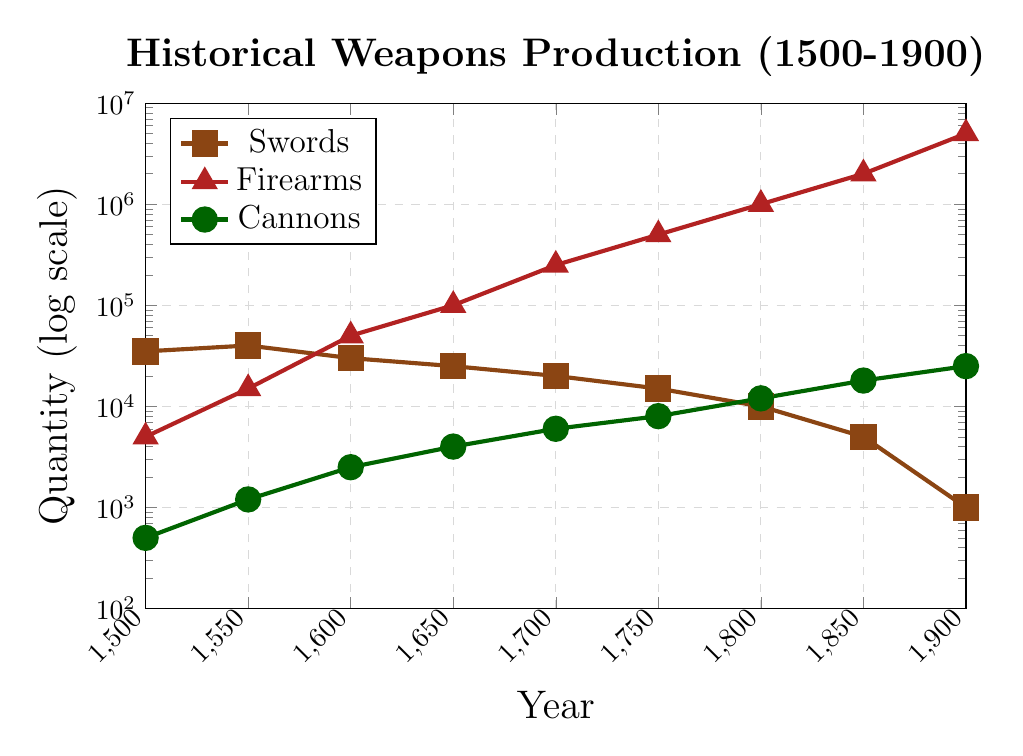What type of weapon saw the most significant increase in production between 1600 and 1700? To find the answer, look at the production values for each weapon type in 1600 and 1700. Compare the differences: Swords: 30000 to 20000 (decrease), Firearms: 50000 to 250000 (increase of 200000), Cannons: 2500 to 6000 (increase of 3500). The most significant increase is for firearms.
Answer: Firearms Compare the number of swords produced in 1500 with the number of cannons produced in 1900. Which number is greater? The production of swords in 1500 is 35000. The production of cannons in 1900 is 25000. Since 35000 is greater than 25000, there were more swords produced in 1500.
Answer: Swords in 1500 What weapon type showed a consistently increasing trend over the entire period from 1500 to 1900? Examine the production trends for each weapon type. Swords showed a decreasing trend. Firearms consistently increased from 5000 to 5000000. Cannons also consistently increased from 500 to 25000. Both firearms and cannons showed consistently increasing trends.
Answer: Firearms and Cannons Calculate the average number of cannons produced per year at the 50-year intervals shown. Add the number of cannons produced at each 50-year interval: 500, 1200, 2500, 4000, 6000, 8000, 12000, 18000, 25000 which sums to 76800. There are 9 data points, so the average is 76800 / 9.
Answer: 8533 Which weapon type had the greatest relative increase from 1550 to 1600 compared to its initial value in 1550? Calculate the relative increase for each type: Swords: (30000 - 40000) / 40000 = -0.25 (decrease), Firearms: (50000 - 15000) / 15000 = 2.33, Cannons: (2500 - 1200) / 1200 = 1.08. Therefore, firearms had the greatest relative increase.
Answer: Firearms By how much did sword production decrease from 1500 to 1900? Subtract the production number in 1900 from the number in 1500: 35000 - 1000 = 34000. Hence, the sword production decreased by 34000.
Answer: 34000 Identify the colors used to represent each weapon type in the plot. Look at the plot's legend to determine the colors. Swords are brown, firearms are red, and cannons are green.
Answer: Brown (swords), Red (firearms), Green (cannons) At what year did firearm production surpass 1,000,000 units? Examine the data points for firearms and find the year this number was first exceeded. In 1800, firearm production reached 1,000,000 units. Therefore, the next data point 1850 (2,000,000) is the first year it surpasses 1,000,000.
Answer: 1850 Which weapon had the largest production quantity in 1750? Refer to the production quantities for 1750: Swords (15000), Firearms (500000), Cannons (8000). The largest quantity produced was firearms.
Answer: Firearms 